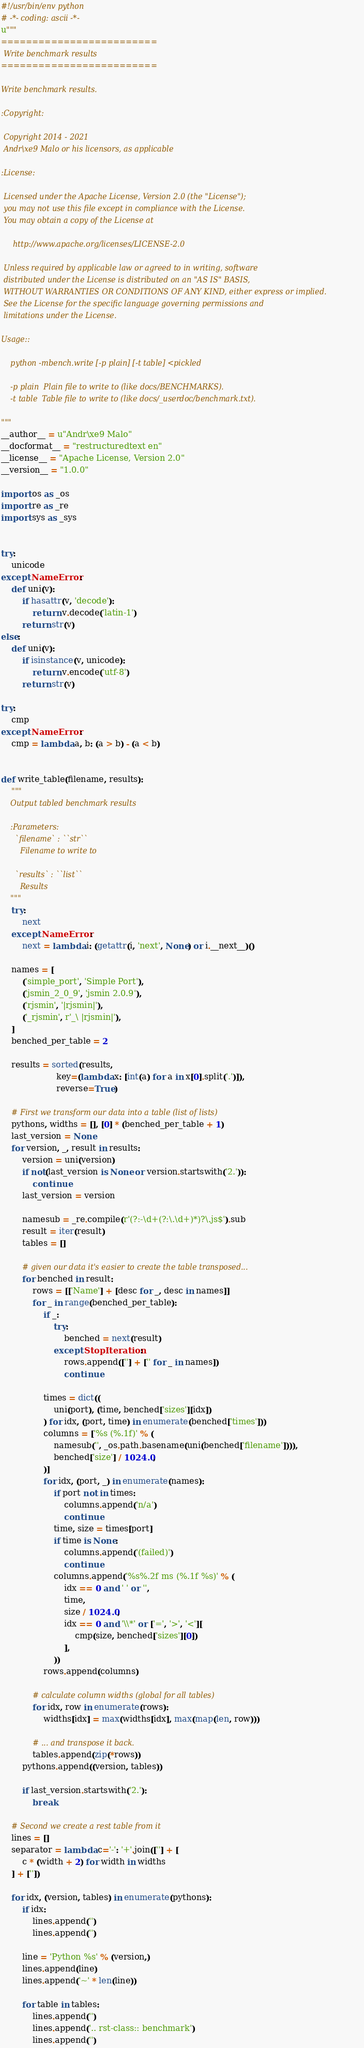Convert code to text. <code><loc_0><loc_0><loc_500><loc_500><_Python_>#!/usr/bin/env python
# -*- coding: ascii -*-
u"""
=========================
 Write benchmark results
=========================

Write benchmark results.

:Copyright:

 Copyright 2014 - 2021
 Andr\xe9 Malo or his licensors, as applicable

:License:

 Licensed under the Apache License, Version 2.0 (the "License");
 you may not use this file except in compliance with the License.
 You may obtain a copy of the License at

     http://www.apache.org/licenses/LICENSE-2.0

 Unless required by applicable law or agreed to in writing, software
 distributed under the License is distributed on an "AS IS" BASIS,
 WITHOUT WARRANTIES OR CONDITIONS OF ANY KIND, either express or implied.
 See the License for the specific language governing permissions and
 limitations under the License.

Usage::

    python -mbench.write [-p plain] [-t table] <pickled

    -p plain  Plain file to write to (like docs/BENCHMARKS).
    -t table  Table file to write to (like docs/_userdoc/benchmark.txt).

"""
__author__ = u"Andr\xe9 Malo"
__docformat__ = "restructuredtext en"
__license__ = "Apache License, Version 2.0"
__version__ = "1.0.0"

import os as _os
import re as _re
import sys as _sys


try:
    unicode
except NameError:
    def uni(v):
        if hasattr(v, 'decode'):
            return v.decode('latin-1')
        return str(v)
else:
    def uni(v):
        if isinstance(v, unicode):
            return v.encode('utf-8')
        return str(v)

try:
    cmp
except NameError:
    cmp = lambda a, b: (a > b) - (a < b)


def write_table(filename, results):
    """
    Output tabled benchmark results

    :Parameters:
      `filename` : ``str``
        Filename to write to

      `results` : ``list``
        Results
    """
    try:
        next
    except NameError:
        next = lambda i: (getattr(i, 'next', None) or i.__next__)()

    names = [
        ('simple_port', 'Simple Port'),
        ('jsmin_2_0_9', 'jsmin 2.0.9'),
        ('rjsmin', '|rjsmin|'),
        ('_rjsmin', r'_\ |rjsmin|'),
    ]
    benched_per_table = 2

    results = sorted(results,
                     key=(lambda x: [int(a) for a in x[0].split('.')]),
                     reverse=True)

    # First we transform our data into a table (list of lists)
    pythons, widths = [], [0] * (benched_per_table + 1)
    last_version = None
    for version, _, result in results:
        version = uni(version)
        if not(last_version is None or version.startswith('2.')):
            continue
        last_version = version

        namesub = _re.compile(r'(?:-\d+(?:\.\d+)*)?\.js$').sub
        result = iter(result)
        tables = []

        # given our data it's easier to create the table transposed...
        for benched in result:
            rows = [['Name'] + [desc for _, desc in names]]
            for _ in range(benched_per_table):
                if _:
                    try:
                        benched = next(result)
                    except StopIteration:
                        rows.append([''] + ['' for _ in names])
                        continue

                times = dict((
                    uni(port), (time, benched['sizes'][idx])
                ) for idx, (port, time) in enumerate(benched['times']))
                columns = ['%s (%.1f)' % (
                    namesub('', _os.path.basename(uni(benched['filename']))),
                    benched['size'] / 1024.0,
                )]
                for idx, (port, _) in enumerate(names):
                    if port not in times:
                        columns.append('n/a')
                        continue
                    time, size = times[port]
                    if time is None:
                        columns.append('(failed)')
                        continue
                    columns.append('%s%.2f ms (%.1f %s)' % (
                        idx == 0 and ' ' or '',
                        time,
                        size / 1024.0,
                        idx == 0 and '\\*' or ['=', '>', '<'][
                            cmp(size, benched['sizes'][0])
                        ],
                    ))
                rows.append(columns)

            # calculate column widths (global for all tables)
            for idx, row in enumerate(rows):
                widths[idx] = max(widths[idx], max(map(len, row)))

            # ... and transpose it back.
            tables.append(zip(*rows))
        pythons.append((version, tables))

        if last_version.startswith('2.'):
            break

    # Second we create a rest table from it
    lines = []
    separator = lambda c='-': '+'.join([''] + [
        c * (width + 2) for width in widths
    ] + [''])

    for idx, (version, tables) in enumerate(pythons):
        if idx:
            lines.append('')
            lines.append('')

        line = 'Python %s' % (version,)
        lines.append(line)
        lines.append('~' * len(line))

        for table in tables:
            lines.append('')
            lines.append('.. rst-class:: benchmark')
            lines.append('')
</code> 